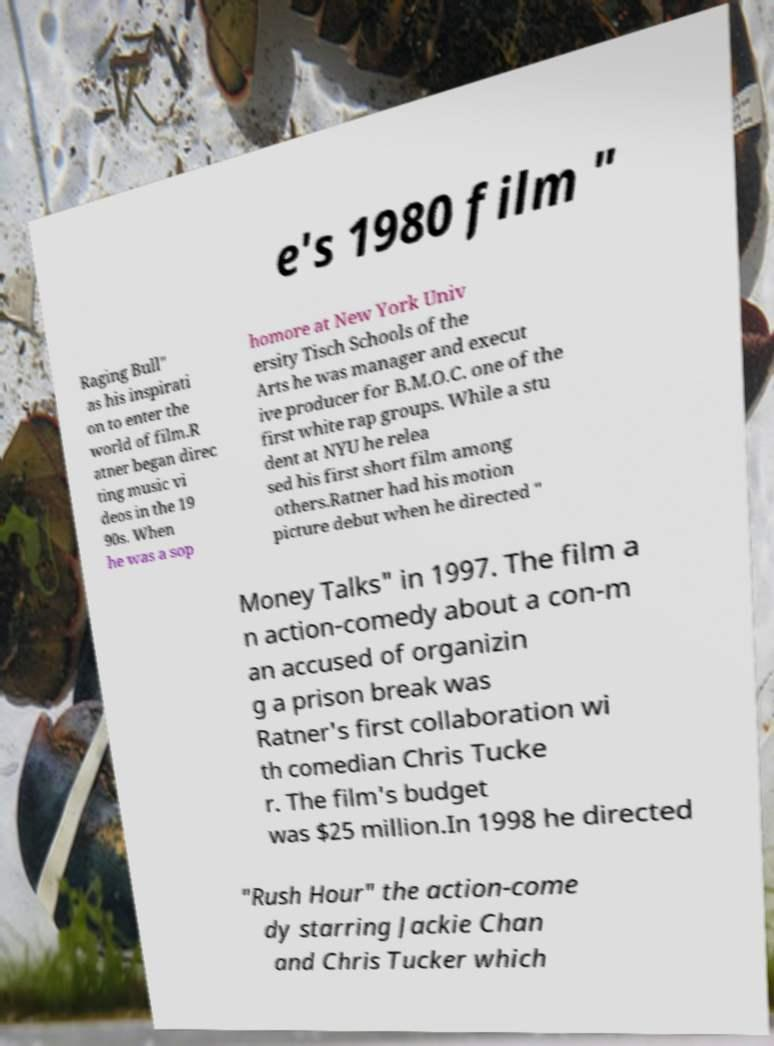Please identify and transcribe the text found in this image. e's 1980 film " Raging Bull" as his inspirati on to enter the world of film.R atner began direc ting music vi deos in the 19 90s. When he was a sop homore at New York Univ ersity Tisch Schools of the Arts he was manager and execut ive producer for B.M.O.C. one of the first white rap groups. While a stu dent at NYU he relea sed his first short film among others.Ratner had his motion picture debut when he directed " Money Talks" in 1997. The film a n action-comedy about a con-m an accused of organizin g a prison break was Ratner's first collaboration wi th comedian Chris Tucke r. The film's budget was $25 million.In 1998 he directed "Rush Hour" the action-come dy starring Jackie Chan and Chris Tucker which 